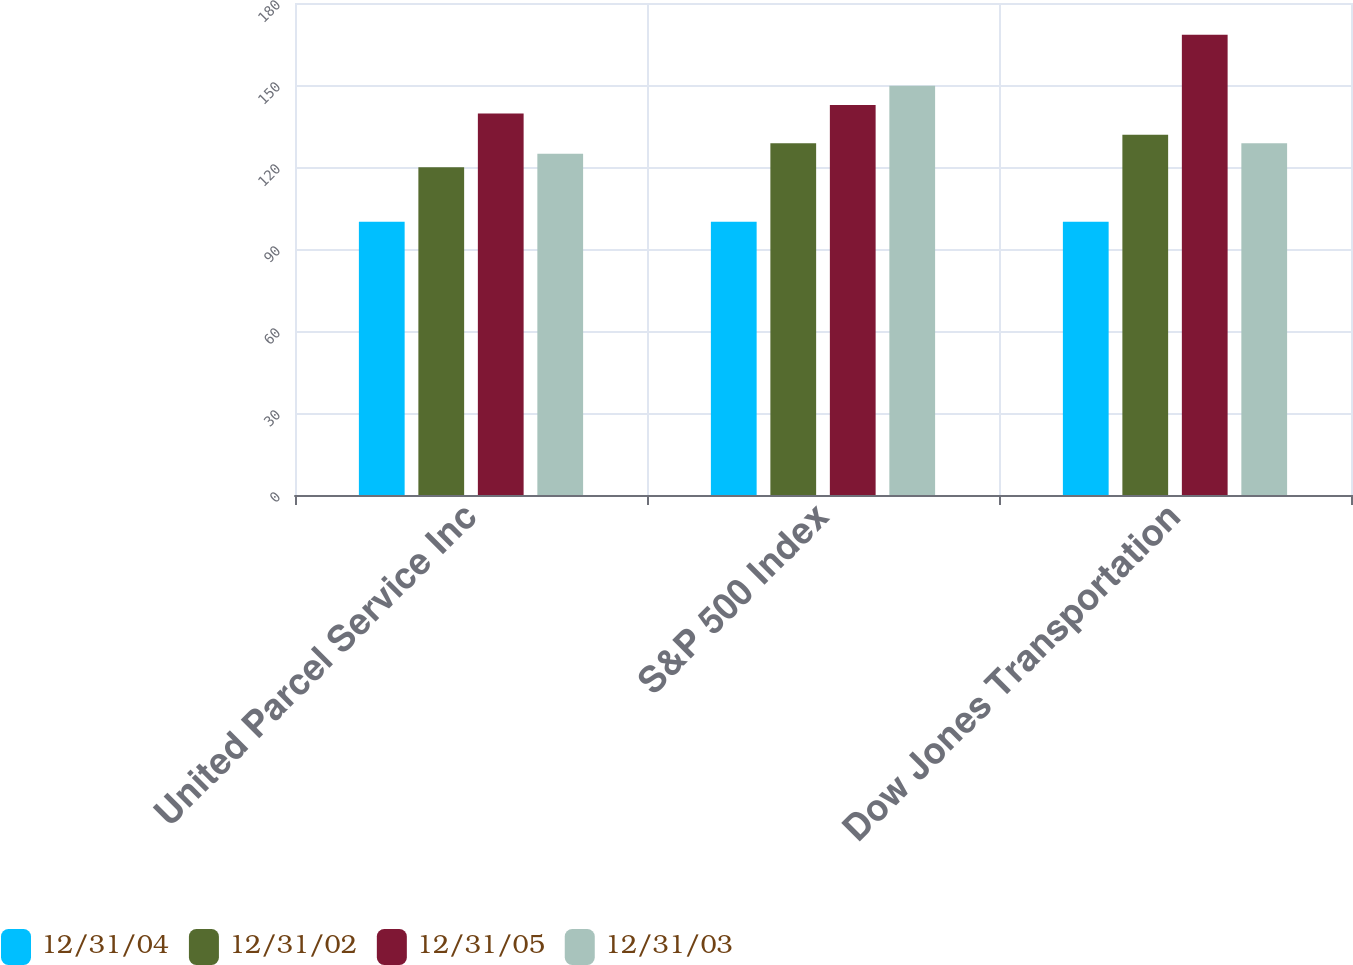Convert chart. <chart><loc_0><loc_0><loc_500><loc_500><stacked_bar_chart><ecel><fcel>United Parcel Service Inc<fcel>S&P 500 Index<fcel>Dow Jones Transportation<nl><fcel>12/31/04<fcel>100<fcel>100<fcel>100<nl><fcel>12/31/02<fcel>119.89<fcel>128.68<fcel>131.84<nl><fcel>12/31/05<fcel>139.55<fcel>142.68<fcel>168.39<nl><fcel>12/31/03<fcel>124.88<fcel>149.69<fcel>128.68<nl></chart> 